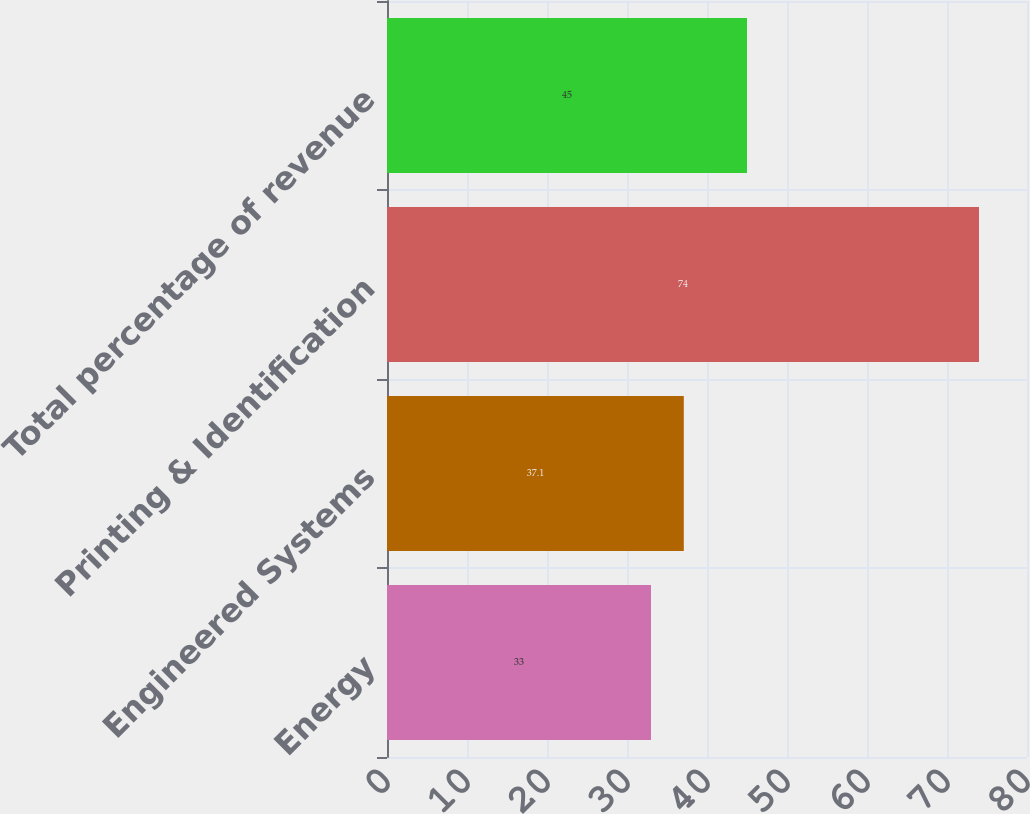<chart> <loc_0><loc_0><loc_500><loc_500><bar_chart><fcel>Energy<fcel>Engineered Systems<fcel>Printing & Identification<fcel>Total percentage of revenue<nl><fcel>33<fcel>37.1<fcel>74<fcel>45<nl></chart> 